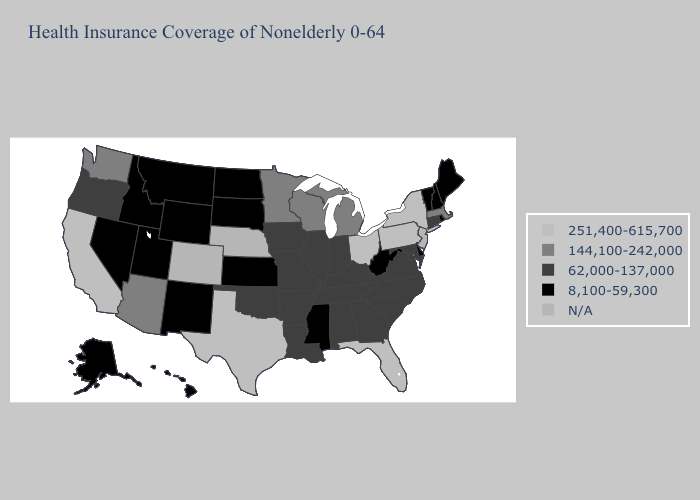What is the value of Illinois?
Concise answer only. 62,000-137,000. What is the highest value in the Northeast ?
Write a very short answer. 251,400-615,700. Name the states that have a value in the range 144,100-242,000?
Be succinct. Arizona, Massachusetts, Michigan, Minnesota, Washington, Wisconsin. Which states have the lowest value in the USA?
Be succinct. Alaska, Delaware, Hawaii, Idaho, Kansas, Maine, Mississippi, Montana, Nevada, New Hampshire, New Mexico, North Dakota, Rhode Island, South Dakota, Utah, Vermont, West Virginia, Wyoming. Among the states that border Illinois , does Wisconsin have the lowest value?
Give a very brief answer. No. Which states have the lowest value in the USA?
Answer briefly. Alaska, Delaware, Hawaii, Idaho, Kansas, Maine, Mississippi, Montana, Nevada, New Hampshire, New Mexico, North Dakota, Rhode Island, South Dakota, Utah, Vermont, West Virginia, Wyoming. Which states hav the highest value in the West?
Short answer required. California. Name the states that have a value in the range 62,000-137,000?
Be succinct. Alabama, Arkansas, Connecticut, Georgia, Illinois, Indiana, Iowa, Kentucky, Louisiana, Maryland, Missouri, North Carolina, Oklahoma, Oregon, South Carolina, Tennessee, Virginia. What is the value of North Dakota?
Quick response, please. 8,100-59,300. Name the states that have a value in the range 62,000-137,000?
Write a very short answer. Alabama, Arkansas, Connecticut, Georgia, Illinois, Indiana, Iowa, Kentucky, Louisiana, Maryland, Missouri, North Carolina, Oklahoma, Oregon, South Carolina, Tennessee, Virginia. What is the highest value in the USA?
Write a very short answer. 251,400-615,700. What is the highest value in the USA?
Give a very brief answer. 251,400-615,700. What is the value of Alaska?
Be succinct. 8,100-59,300. Which states have the lowest value in the MidWest?
Write a very short answer. Kansas, North Dakota, South Dakota. 